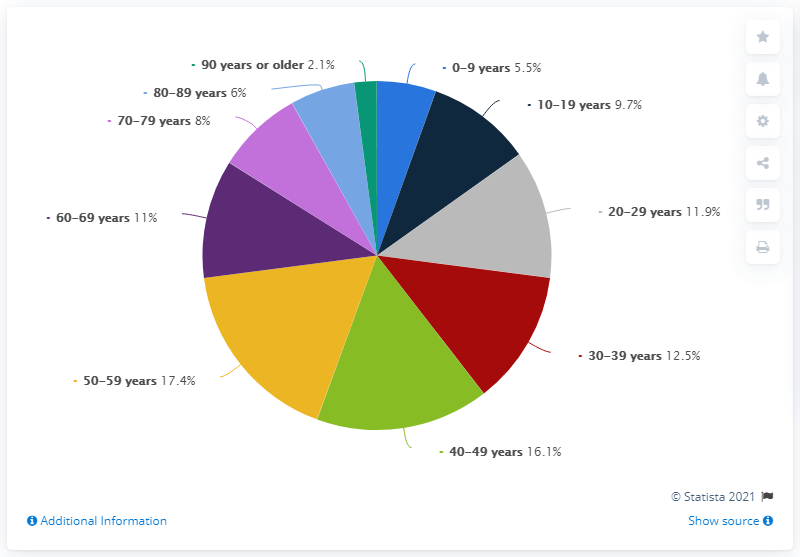Specify some key components in this picture. The smallest percentage value in this chart is 2.1%. The question asks for the largest percentage value in a chart, with a specific numerical value of 17.4. 